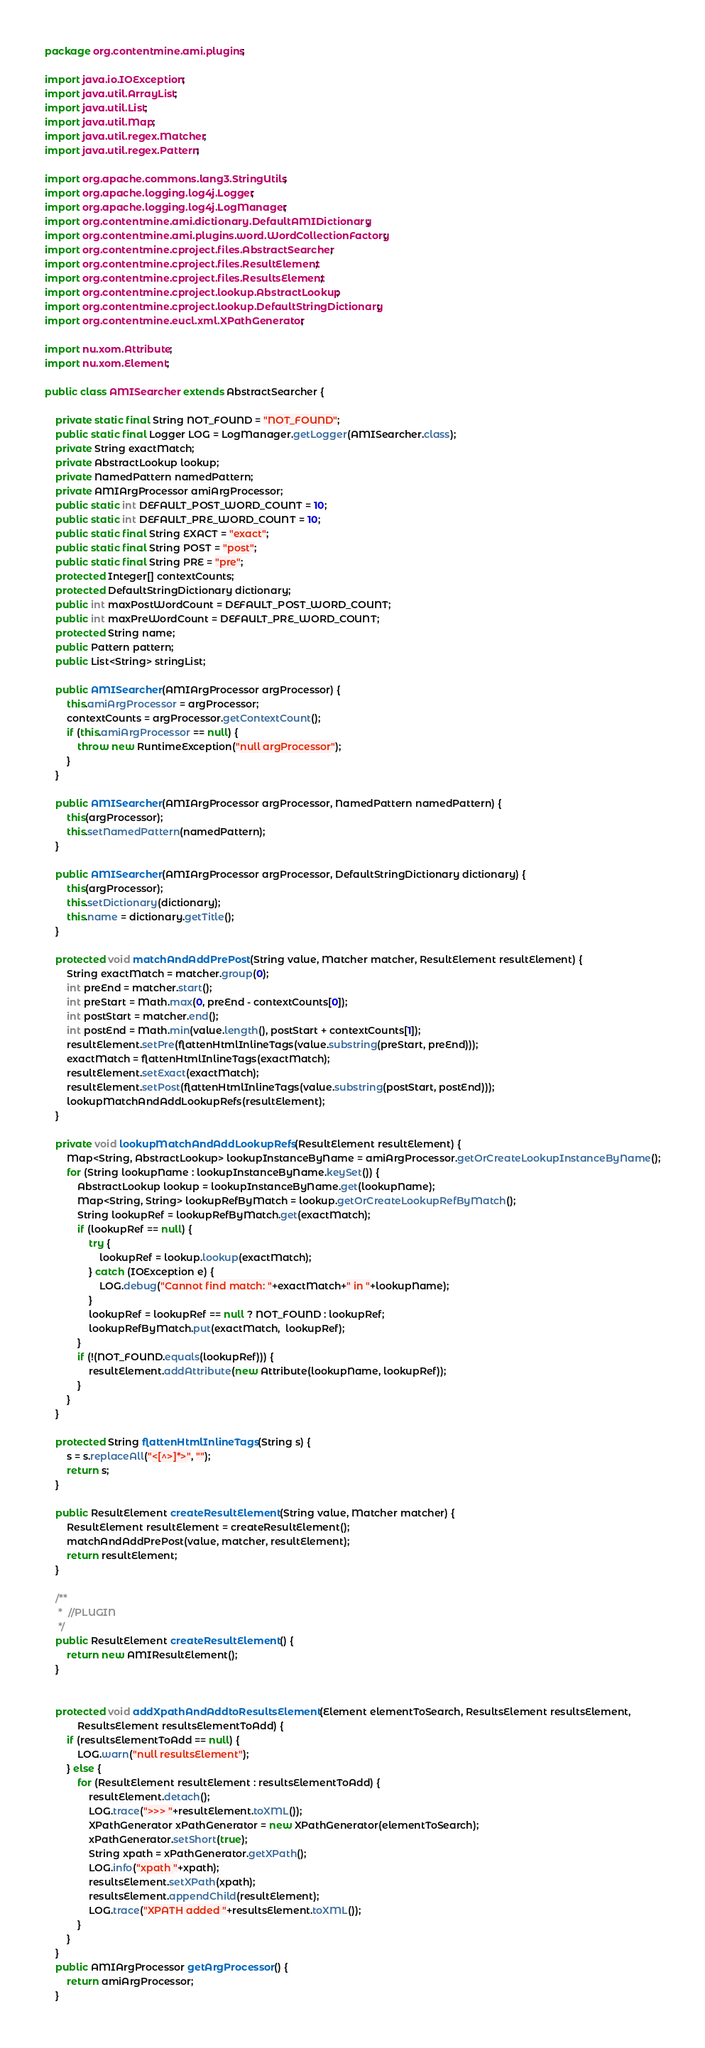Convert code to text. <code><loc_0><loc_0><loc_500><loc_500><_Java_>package org.contentmine.ami.plugins;

import java.io.IOException;
import java.util.ArrayList;
import java.util.List;
import java.util.Map;
import java.util.regex.Matcher;
import java.util.regex.Pattern;

import org.apache.commons.lang3.StringUtils;
import org.apache.logging.log4j.Logger;
import org.apache.logging.log4j.LogManager;
import org.contentmine.ami.dictionary.DefaultAMIDictionary;
import org.contentmine.ami.plugins.word.WordCollectionFactory;
import org.contentmine.cproject.files.AbstractSearcher;
import org.contentmine.cproject.files.ResultElement;
import org.contentmine.cproject.files.ResultsElement;
import org.contentmine.cproject.lookup.AbstractLookup;
import org.contentmine.cproject.lookup.DefaultStringDictionary;
import org.contentmine.eucl.xml.XPathGenerator;

import nu.xom.Attribute;
import nu.xom.Element;

public class AMISearcher extends AbstractSearcher {

	private static final String NOT_FOUND = "NOT_FOUND";
	public static final Logger LOG = LogManager.getLogger(AMISearcher.class);
	private String exactMatch;
	private AbstractLookup lookup;
	private NamedPattern namedPattern;
	private AMIArgProcessor amiArgProcessor;
	public static int DEFAULT_POST_WORD_COUNT = 10;
	public static int DEFAULT_PRE_WORD_COUNT = 10;
	public static final String EXACT = "exact";
	public static final String POST = "post";
	public static final String PRE = "pre";
	protected Integer[] contextCounts;
	protected DefaultStringDictionary dictionary;
	public int maxPostWordCount = DEFAULT_POST_WORD_COUNT;
	public int maxPreWordCount = DEFAULT_PRE_WORD_COUNT;
	protected String name;
	public Pattern pattern;
	public List<String> stringList;
	
	public AMISearcher(AMIArgProcessor argProcessor) {
		this.amiArgProcessor = argProcessor;
		contextCounts = argProcessor.getContextCount();
		if (this.amiArgProcessor == null) {
			throw new RuntimeException("null argProcessor");
		}
	}

	public AMISearcher(AMIArgProcessor argProcessor, NamedPattern namedPattern) {
		this(argProcessor);
		this.setNamedPattern(namedPattern);
	}

	public AMISearcher(AMIArgProcessor argProcessor, DefaultStringDictionary dictionary) {
		this(argProcessor);
		this.setDictionary(dictionary);
		this.name = dictionary.getTitle();
	}

	protected void matchAndAddPrePost(String value, Matcher matcher, ResultElement resultElement) {
		String exactMatch = matcher.group(0);
		int preEnd = matcher.start();
		int preStart = Math.max(0, preEnd - contextCounts[0]);
		int postStart = matcher.end();
		int postEnd = Math.min(value.length(), postStart + contextCounts[1]);
		resultElement.setPre(flattenHtmlInlineTags(value.substring(preStart, preEnd)));
		exactMatch = flattenHtmlInlineTags(exactMatch);
		resultElement.setExact(exactMatch);
		resultElement.setPost(flattenHtmlInlineTags(value.substring(postStart, postEnd)));
		lookupMatchAndAddLookupRefs(resultElement);
	}

	private void lookupMatchAndAddLookupRefs(ResultElement resultElement) {
		Map<String, AbstractLookup> lookupInstanceByName = amiArgProcessor.getOrCreateLookupInstanceByName();
		for (String lookupName : lookupInstanceByName.keySet()) {
			AbstractLookup lookup = lookupInstanceByName.get(lookupName);
			Map<String, String> lookupRefByMatch = lookup.getOrCreateLookupRefByMatch();
			String lookupRef = lookupRefByMatch.get(exactMatch);
			if (lookupRef == null) {
				try {
					lookupRef = lookup.lookup(exactMatch);
				} catch (IOException e) {
					LOG.debug("Cannot find match: "+exactMatch+" in "+lookupName);
				}
				lookupRef = lookupRef == null ? NOT_FOUND : lookupRef;
				lookupRefByMatch.put(exactMatch,  lookupRef);
			}
			if (!(NOT_FOUND.equals(lookupRef))) {
				resultElement.addAttribute(new Attribute(lookupName, lookupRef));
			}
		}
	}
	
	protected String flattenHtmlInlineTags(String s) {
		s = s.replaceAll("<[^>]*>", "");
		return s;
	}

	public ResultElement createResultElement(String value, Matcher matcher) {
		ResultElement resultElement = createResultElement();
		matchAndAddPrePost(value, matcher, resultElement);
		return resultElement;
	}
	
	/**
	 *  //PLUGIN
	 */
	public ResultElement createResultElement() {
		return new AMIResultElement();
	}


	protected void addXpathAndAddtoResultsElement(Element elementToSearch, ResultsElement resultsElement,
			ResultsElement resultsElementToAdd) {
		if (resultsElementToAdd == null) {
			LOG.warn("null resultsElement");
		} else {
			for (ResultElement resultElement : resultsElementToAdd) {
				resultElement.detach();
				LOG.trace(">>> "+resultElement.toXML());
				XPathGenerator xPathGenerator = new XPathGenerator(elementToSearch);
				xPathGenerator.setShort(true);
				String xpath = xPathGenerator.getXPath();
				LOG.info("xpath "+xpath);
				resultsElement.setXPath(xpath);
				resultsElement.appendChild(resultElement);
				LOG.trace("XPATH added "+resultsElement.toXML());
			}
		}
	}
	public AMIArgProcessor getArgProcessor() {
		return amiArgProcessor;
	}
</code> 